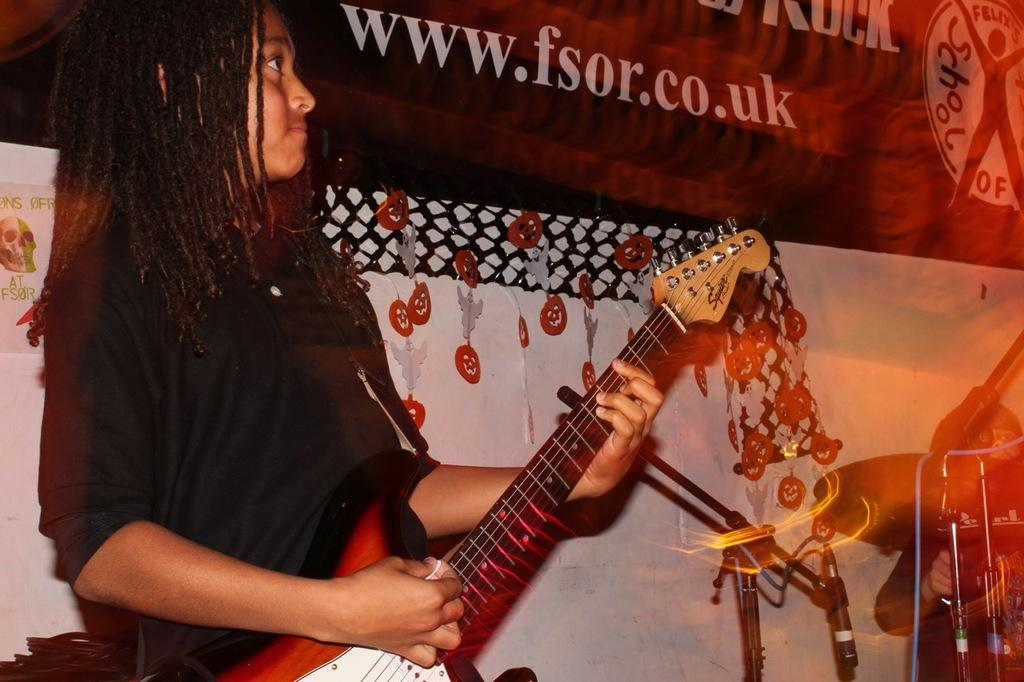What is the person in the image doing? The person is playing a guitar. What is the person wearing in the image? The person is wearing a black t-shirt. What can be seen in the background of the image? There is a banner in the background of the image. What is written on the banner? "www.fsr.co.uk" is written on the banner. How does the person tie a knot with their hair while playing the guitar? The person is not tying a knot with their hair in the image; they are simply playing the guitar. What type of boot is the person wearing in the image? There is no boot visible in the image; the person is wearing a black t-shirt. 